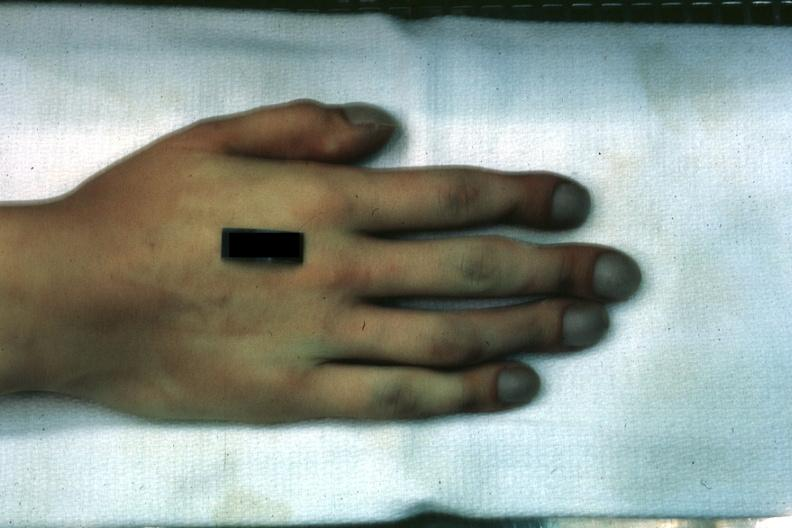what does this image show?
Answer the question using a single word or phrase. Case of transposition of great vessels with vsd age 22 yrs 